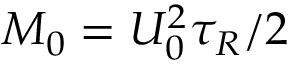Convert formula to latex. <formula><loc_0><loc_0><loc_500><loc_500>M _ { 0 } = U _ { 0 } ^ { 2 } \tau _ { R } / 2</formula> 